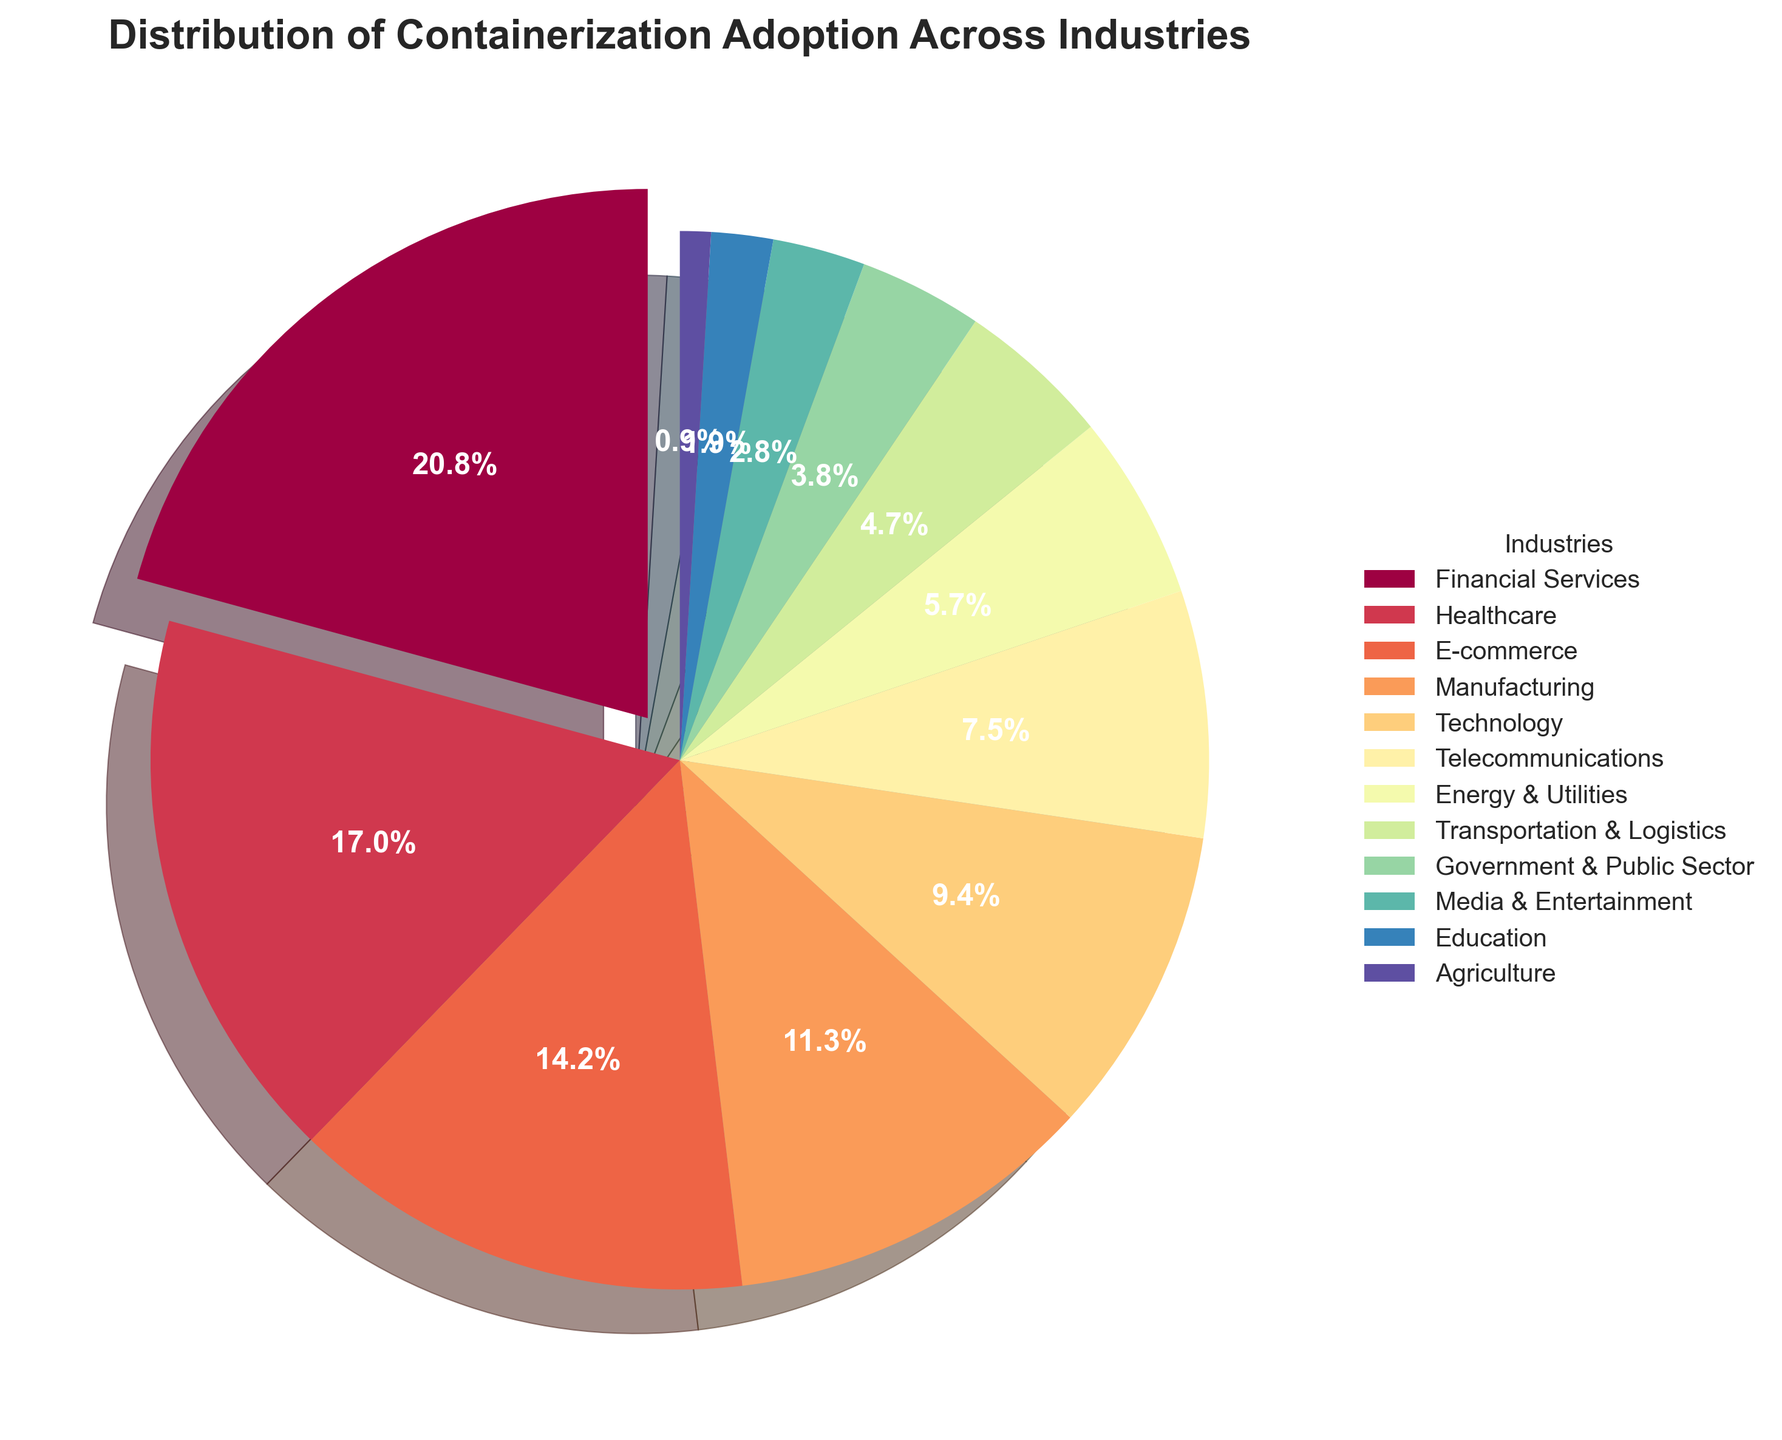What's the largest industry sector in terms of containerization adoption? The largest sector is shown as an exploded slice, which signifies the highest adoption percentage. According to the figure, the Financial Services sector stands out prominently.
Answer: Financial Services Which industry has a 15% adoption rate? Look for the sector labeled with "15%" in the pie chart. This label is associated with the E-commerce sector.
Answer: E-commerce What is the combined adoption percentage of the top three sectors? The top three sectors based on their adoption percentages are Financial Services (22%), Healthcare (18%), and E-commerce (15%). Their combined adoption is calculated as 22 + 18 + 15 = 55%.
Answer: 55% Compare the adoption percentages of Technology and Agriculture. Which one has a higher adoption rate? Check the slices associated with Technology and Agriculture. Technology has a 10% adoption rate, while Agriculture has a 1% adoption rate. Clearly, Technology is higher.
Answer: Technology What percent of industries have an adoption rate lower than 10%? Identify the sectors with adoption rates lower than 10%: Telecommunications (8%), Energy & Utilities (6%), Transportation & Logistics (5%), Government & Public Sector (4%), Media & Entertainment (3%), Education (2%), and Agriculture (1%). Count them to find there are 7 out of 12 sectors, then calculate (7/12) * 100 ≈ 58.33%.
Answer: Approximately 58.33% How does the adoption rate of Telecommunications compare to that of Healthcare? Telecommunications is marked with an 8% adoption rate, while Healthcare is marked with 18%. Therefore, Healthcare has a higher adoption rate than Telecommunications.
Answer: Healthcare Which sector has the smallest adoption percentage and what is it? The smallest sector is visually the smallest slice labeled "1%". This corresponds to the Agriculture sector.
Answer: Agriculture What is the average adoption percentage for all sectors combined? Sum all adoption percentages and divide by the number of sectors: (22 + 18 + 15 + 12 + 10 + 8 + 6 + 5 + 4 + 3 + 2 + 1) / 12 = 106 / 12 ≈ 8.83%.
Answer: Approximately 8.83% Which two sectors combined have an adoption percentage equivalent to that of the Financial Services sector? The Financial Services sector has a 22% adoption rate. Two sectors whose combined rates equal 22% are Technology (10%) and Education (2%) combined with Government & Public Sector (10%).
Answer: Technology and Government & Public Sector What is the total percentage of adoption for sectors outside the top five? Identify the top five sectors (Financial Services, Healthcare, E-commerce, Manufacturing, Technology). The rest are: Telecommunications (8%), Energy & Utilities (6%), Transportation & Logistics (5%), Government & Public Sector (4%), Media & Entertainment (3%), Education (2%), and Agriculture (1%). Sum their percentages: 8 + 6 + 5 + 4 + 3 + 2 + 1 = 29%.
Answer: 29% 